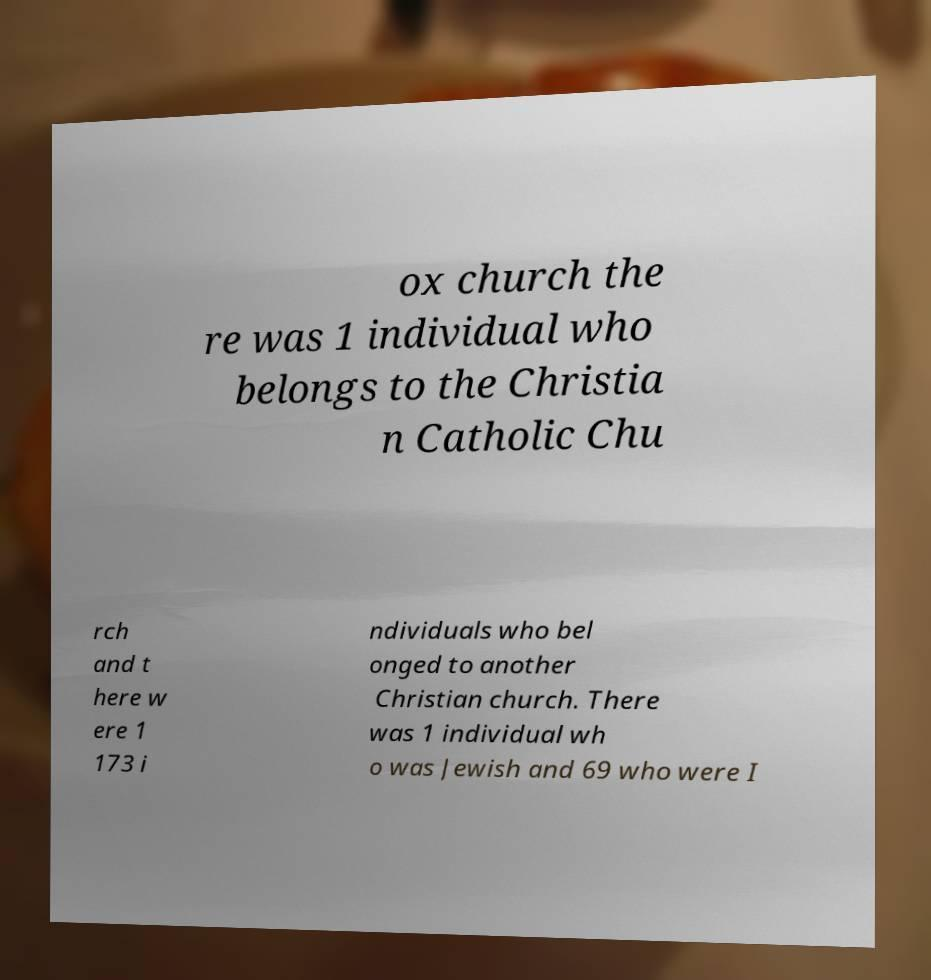Please read and relay the text visible in this image. What does it say? ox church the re was 1 individual who belongs to the Christia n Catholic Chu rch and t here w ere 1 173 i ndividuals who bel onged to another Christian church. There was 1 individual wh o was Jewish and 69 who were I 